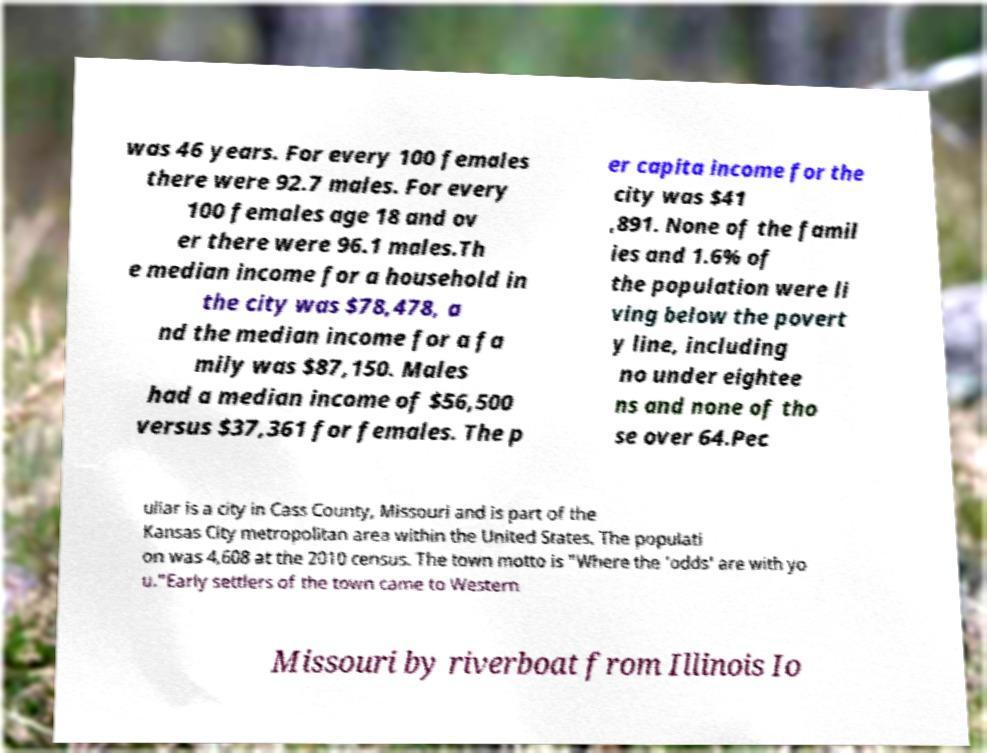For documentation purposes, I need the text within this image transcribed. Could you provide that? was 46 years. For every 100 females there were 92.7 males. For every 100 females age 18 and ov er there were 96.1 males.Th e median income for a household in the city was $78,478, a nd the median income for a fa mily was $87,150. Males had a median income of $56,500 versus $37,361 for females. The p er capita income for the city was $41 ,891. None of the famil ies and 1.6% of the population were li ving below the povert y line, including no under eightee ns and none of tho se over 64.Pec uliar is a city in Cass County, Missouri and is part of the Kansas City metropolitan area within the United States. The populati on was 4,608 at the 2010 census. The town motto is "Where the 'odds' are with yo u."Early settlers of the town came to Western Missouri by riverboat from Illinois Io 